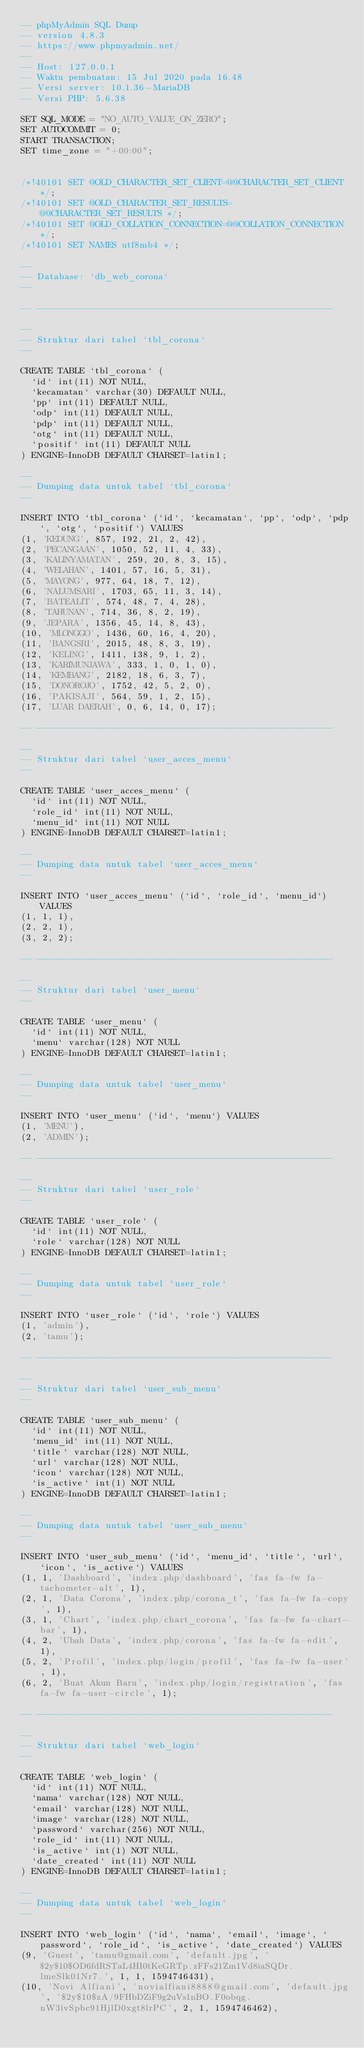Convert code to text. <code><loc_0><loc_0><loc_500><loc_500><_SQL_>-- phpMyAdmin SQL Dump
-- version 4.8.3
-- https://www.phpmyadmin.net/
--
-- Host: 127.0.0.1
-- Waktu pembuatan: 15 Jul 2020 pada 16.48
-- Versi server: 10.1.36-MariaDB
-- Versi PHP: 5.6.38

SET SQL_MODE = "NO_AUTO_VALUE_ON_ZERO";
SET AUTOCOMMIT = 0;
START TRANSACTION;
SET time_zone = "+00:00";


/*!40101 SET @OLD_CHARACTER_SET_CLIENT=@@CHARACTER_SET_CLIENT */;
/*!40101 SET @OLD_CHARACTER_SET_RESULTS=@@CHARACTER_SET_RESULTS */;
/*!40101 SET @OLD_COLLATION_CONNECTION=@@COLLATION_CONNECTION */;
/*!40101 SET NAMES utf8mb4 */;

--
-- Database: `db_web_corona`
--

-- --------------------------------------------------------

--
-- Struktur dari tabel `tbl_corona`
--

CREATE TABLE `tbl_corona` (
  `id` int(11) NOT NULL,
  `kecamatan` varchar(30) DEFAULT NULL,
  `pp` int(11) DEFAULT NULL,
  `odp` int(11) DEFAULT NULL,
  `pdp` int(11) DEFAULT NULL,
  `otg` int(11) DEFAULT NULL,
  `positif` int(11) DEFAULT NULL
) ENGINE=InnoDB DEFAULT CHARSET=latin1;

--
-- Dumping data untuk tabel `tbl_corona`
--

INSERT INTO `tbl_corona` (`id`, `kecamatan`, `pp`, `odp`, `pdp`, `otg`, `positif`) VALUES
(1, 'KEDUNG', 857, 192, 21, 2, 42),
(2, 'PECANGAAN', 1050, 52, 11, 4, 33),
(3, 'KALINYAMATAN', 259, 20, 8, 3, 15),
(4, 'WELAHAN', 1401, 57, 16, 5, 31),
(5, 'MAYONG', 977, 64, 18, 7, 12),
(6, 'NALUMSARI', 1703, 65, 11, 3, 14),
(7, 'BATEALIT', 574, 48, 7, 4, 28),
(8, 'TAHUNAN', 714, 36, 8, 2, 19),
(9, 'JEPARA', 1356, 45, 14, 8, 43),
(10, 'MLONGGO', 1436, 60, 16, 4, 20),
(11, 'BANGSRI', 2015, 48, 8, 3, 19),
(12, 'KELING', 1411, 138, 9, 1, 2),
(13, 'KARIMUNJAWA', 333, 1, 0, 1, 0),
(14, 'KEMBANG', 2182, 18, 6, 3, 7),
(15, 'DONOROJO', 1752, 42, 5, 2, 0),
(16, 'PAKISAJI', 564, 59, 1, 2, 15),
(17, 'LUAR DAERAH', 0, 6, 14, 0, 17);

-- --------------------------------------------------------

--
-- Struktur dari tabel `user_acces_menu`
--

CREATE TABLE `user_acces_menu` (
  `id` int(11) NOT NULL,
  `role_id` int(11) NOT NULL,
  `menu_id` int(11) NOT NULL
) ENGINE=InnoDB DEFAULT CHARSET=latin1;

--
-- Dumping data untuk tabel `user_acces_menu`
--

INSERT INTO `user_acces_menu` (`id`, `role_id`, `menu_id`) VALUES
(1, 1, 1),
(2, 2, 1),
(3, 2, 2);

-- --------------------------------------------------------

--
-- Struktur dari tabel `user_menu`
--

CREATE TABLE `user_menu` (
  `id` int(11) NOT NULL,
  `menu` varchar(128) NOT NULL
) ENGINE=InnoDB DEFAULT CHARSET=latin1;

--
-- Dumping data untuk tabel `user_menu`
--

INSERT INTO `user_menu` (`id`, `menu`) VALUES
(1, 'MENU'),
(2, 'ADMIN');

-- --------------------------------------------------------

--
-- Struktur dari tabel `user_role`
--

CREATE TABLE `user_role` (
  `id` int(11) NOT NULL,
  `role` varchar(128) NOT NULL
) ENGINE=InnoDB DEFAULT CHARSET=latin1;

--
-- Dumping data untuk tabel `user_role`
--

INSERT INTO `user_role` (`id`, `role`) VALUES
(1, 'admin'),
(2, 'tamu');

-- --------------------------------------------------------

--
-- Struktur dari tabel `user_sub_menu`
--

CREATE TABLE `user_sub_menu` (
  `id` int(11) NOT NULL,
  `menu_id` int(11) NOT NULL,
  `title` varchar(128) NOT NULL,
  `url` varchar(128) NOT NULL,
  `icon` varchar(128) NOT NULL,
  `is_active` int(1) NOT NULL
) ENGINE=InnoDB DEFAULT CHARSET=latin1;

--
-- Dumping data untuk tabel `user_sub_menu`
--

INSERT INTO `user_sub_menu` (`id`, `menu_id`, `title`, `url`, `icon`, `is_active`) VALUES
(1, 1, 'Dashboard', 'index.php/dashboard', 'fas fa-fw fa-tachometer-alt', 1),
(2, 1, 'Data Corona', 'index.php/corona_t', 'fas fa-fw fa-copy', 1),
(3, 1, 'Chart', 'index.php/chart_corona', 'fas fa-fw fa-chart-bar', 1),
(4, 2, 'Ubah Data', 'index.php/corona', 'fas fa-fw fa-edit', 1),
(5, 2, 'Profil', 'index.php/login/profil', 'fas fa-fw fa-user', 1),
(6, 2, 'Buat Akun Baru', 'index.php/login/registration', 'fas fa-fw fa-user-circle', 1);

-- --------------------------------------------------------

--
-- Struktur dari tabel `web_login`
--

CREATE TABLE `web_login` (
  `id` int(11) NOT NULL,
  `nama` varchar(128) NOT NULL,
  `email` varchar(128) NOT NULL,
  `image` varchar(128) NOT NULL,
  `password` varchar(256) NOT NULL,
  `role_id` int(11) NOT NULL,
  `is_active` int(1) NOT NULL,
  `date_created` int(11) NOT NULL
) ENGINE=InnoDB DEFAULT CHARSET=latin1;

--
-- Dumping data untuk tabel `web_login`
--

INSERT INTO `web_login` (`id`, `nama`, `email`, `image`, `password`, `role_id`, `is_active`, `date_created`) VALUES
(9, 'Guest', 'tamu@gmail.com', 'default.jpg', '$2y$10$OD6fdRSTaL4HI0tKeGRTp.zFFs21Zm1Vd8iaSQDr.lmeSlk01Nr7.', 1, 1, 1594746431),
(10, 'Novi Alfiani', 'novialfiani8888@gmail.com', 'default.jpg', '$2y$10$zA/9FHbDZiF9g2uVs1nBO.F0obqg.nW3ivSpbc91HjlD0xgt8lrPC', 2, 1, 1594746462),</code> 